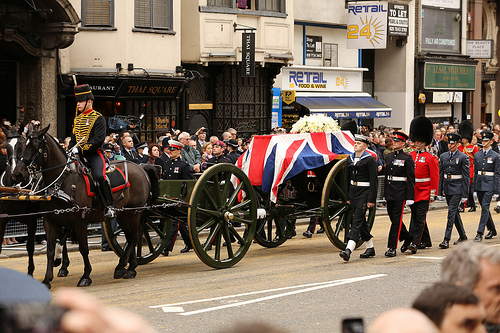Is this a green wagon? Yes, this is indeed a green wagon. 